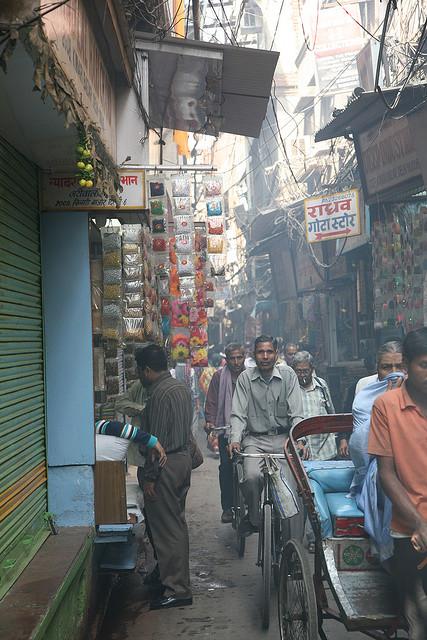How many bike riders are there?
Quick response, please. 2. What language are the signs in?
Write a very short answer. Chinese. Is anyone wearing a hat?
Give a very brief answer. No. Is the street crowded?
Give a very brief answer. Yes. 